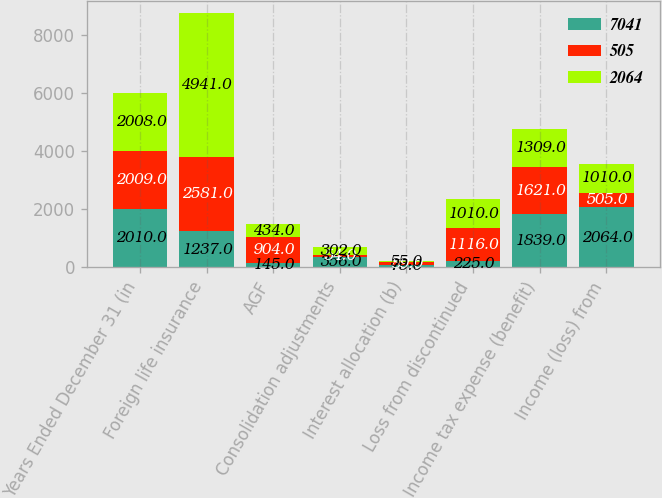Convert chart to OTSL. <chart><loc_0><loc_0><loc_500><loc_500><stacked_bar_chart><ecel><fcel>Years Ended December 31 (in<fcel>Foreign life insurance<fcel>AGF<fcel>Consolidation adjustments<fcel>Interest allocation (b)<fcel>Loss from discontinued<fcel>Income tax expense (benefit)<fcel>Income (loss) from<nl><fcel>7041<fcel>2010<fcel>1237<fcel>145<fcel>356<fcel>75<fcel>225<fcel>1839<fcel>2064<nl><fcel>505<fcel>2009<fcel>2581<fcel>904<fcel>54<fcel>89<fcel>1116<fcel>1621<fcel>505<nl><fcel>2064<fcel>2008<fcel>4941<fcel>434<fcel>302<fcel>55<fcel>1010<fcel>1309<fcel>1010<nl></chart> 